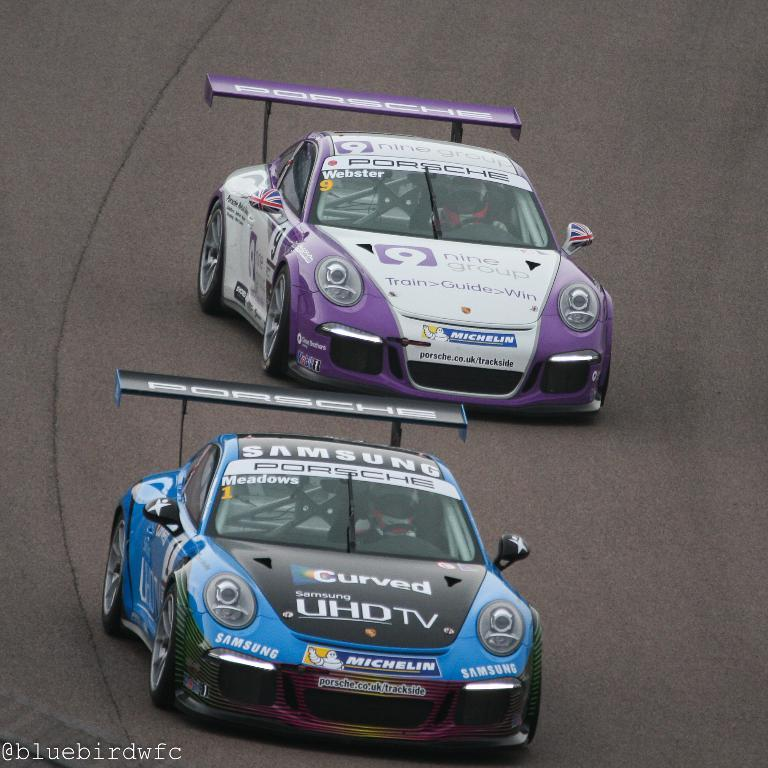Where was the image taken? The image was clicked outside the city. What can be seen in the center of the image? There are two cars running on the road in the center of the image. Is there any text visible in the image? Yes, there is text in the bottom left corner of the image. Can you see any parents with their children walking on the sidewalk in the image? There is no sidewalk or parents with children visible in the image. 